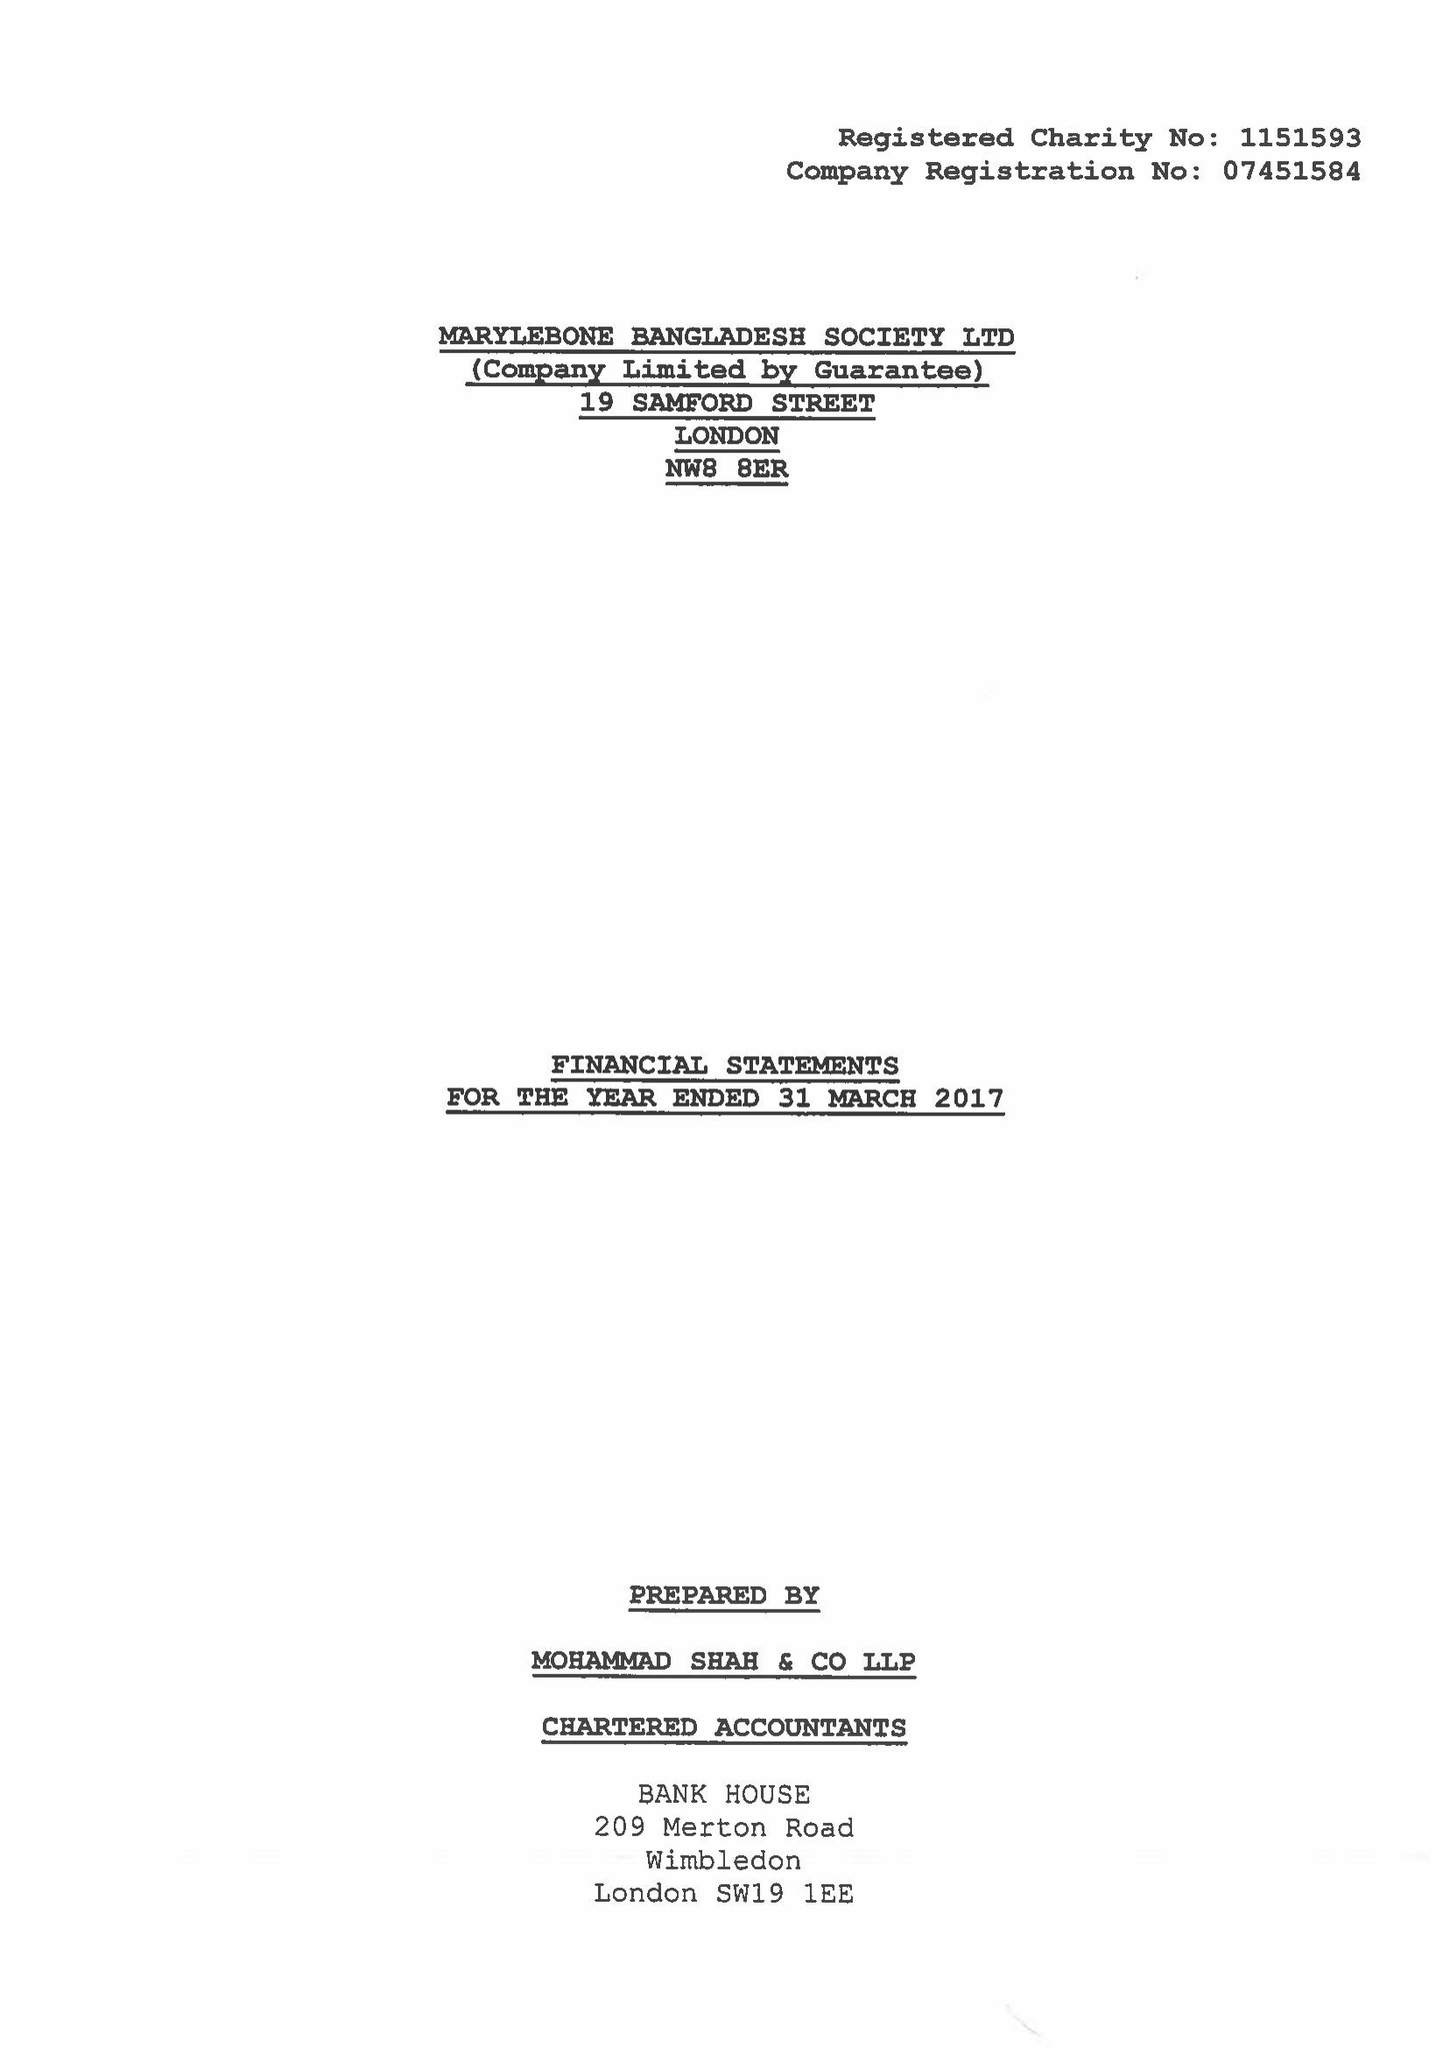What is the value for the address__street_line?
Answer the question using a single word or phrase. 19 SAMFORD STREET 